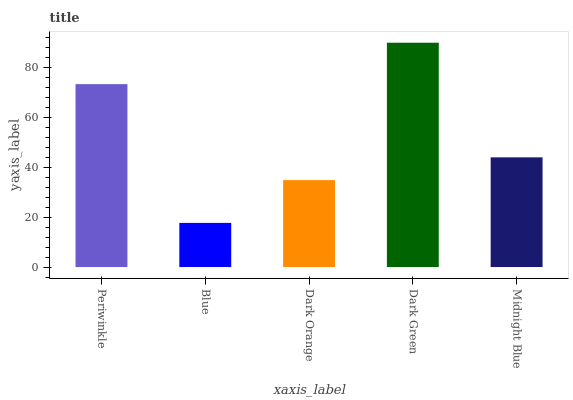Is Blue the minimum?
Answer yes or no. Yes. Is Dark Green the maximum?
Answer yes or no. Yes. Is Dark Orange the minimum?
Answer yes or no. No. Is Dark Orange the maximum?
Answer yes or no. No. Is Dark Orange greater than Blue?
Answer yes or no. Yes. Is Blue less than Dark Orange?
Answer yes or no. Yes. Is Blue greater than Dark Orange?
Answer yes or no. No. Is Dark Orange less than Blue?
Answer yes or no. No. Is Midnight Blue the high median?
Answer yes or no. Yes. Is Midnight Blue the low median?
Answer yes or no. Yes. Is Dark Green the high median?
Answer yes or no. No. Is Dark Orange the low median?
Answer yes or no. No. 